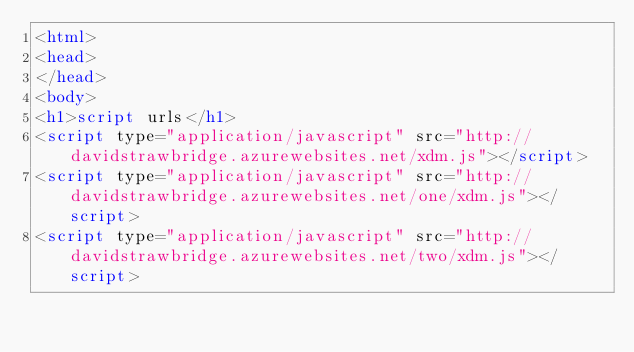<code> <loc_0><loc_0><loc_500><loc_500><_HTML_><html>
<head>
</head>
<body>
<h1>script urls</h1>
<script type="application/javascript" src="http://davidstrawbridge.azurewebsites.net/xdm.js"></script>
<script type="application/javascript" src="http://davidstrawbridge.azurewebsites.net/one/xdm.js"></script>
<script type="application/javascript" src="http://davidstrawbridge.azurewebsites.net/two/xdm.js"></script></code> 